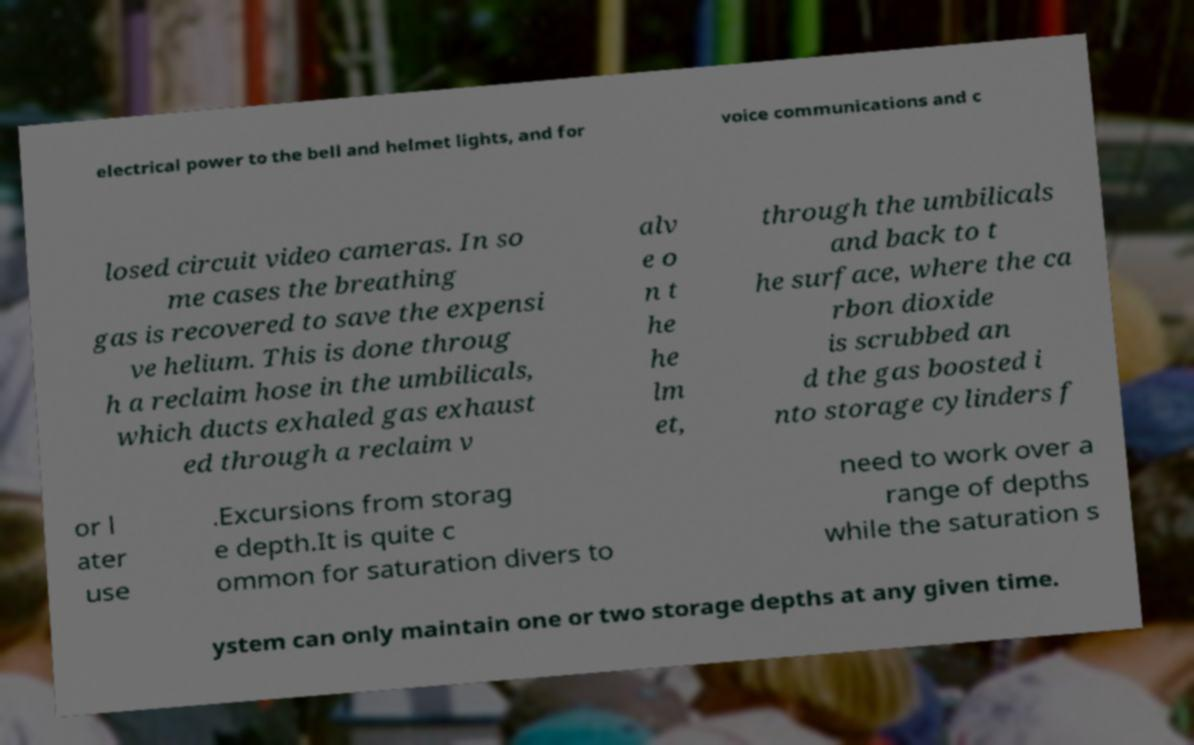Please identify and transcribe the text found in this image. electrical power to the bell and helmet lights, and for voice communications and c losed circuit video cameras. In so me cases the breathing gas is recovered to save the expensi ve helium. This is done throug h a reclaim hose in the umbilicals, which ducts exhaled gas exhaust ed through a reclaim v alv e o n t he he lm et, through the umbilicals and back to t he surface, where the ca rbon dioxide is scrubbed an d the gas boosted i nto storage cylinders f or l ater use .Excursions from storag e depth.It is quite c ommon for saturation divers to need to work over a range of depths while the saturation s ystem can only maintain one or two storage depths at any given time. 